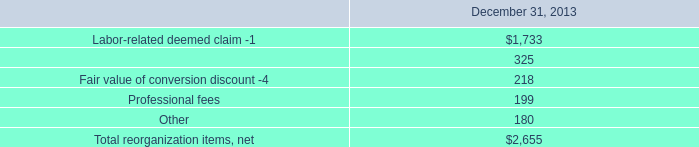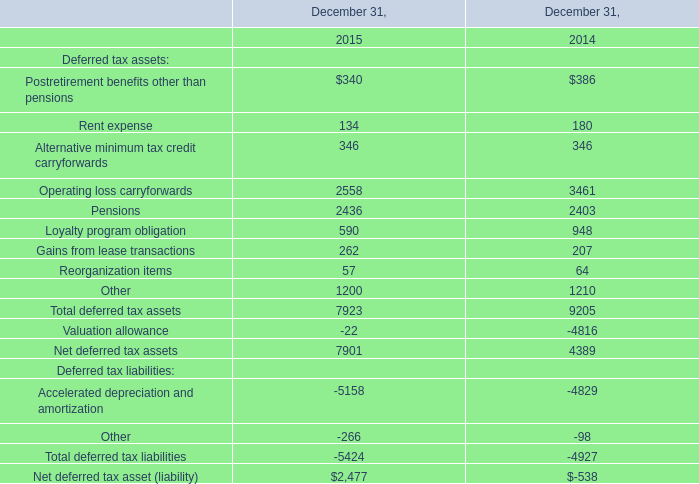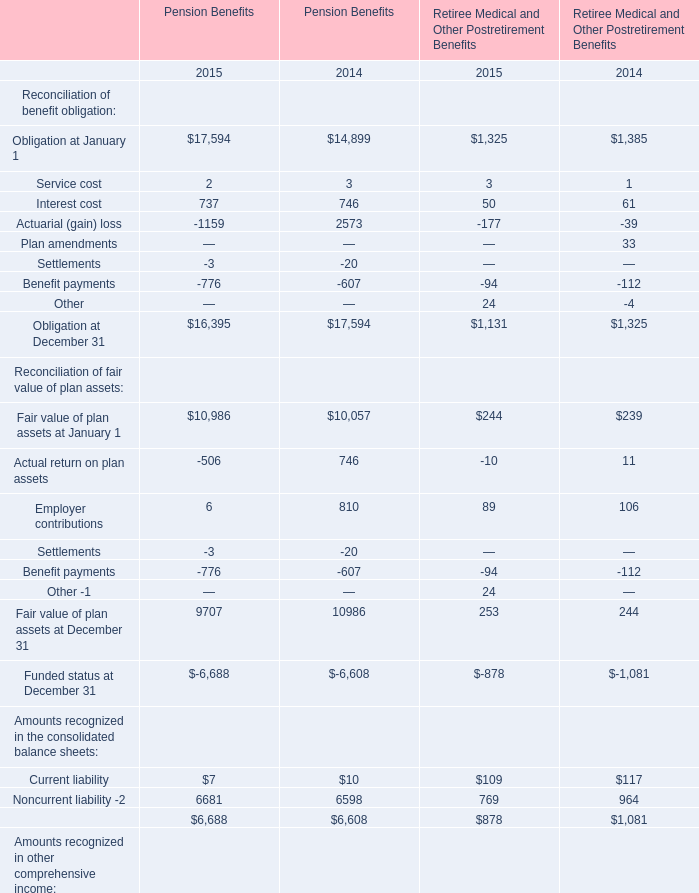what is the percent of the professional fees as part of the total re-organization costs 
Computations: (1990 / 2655)
Answer: 0.74953. 